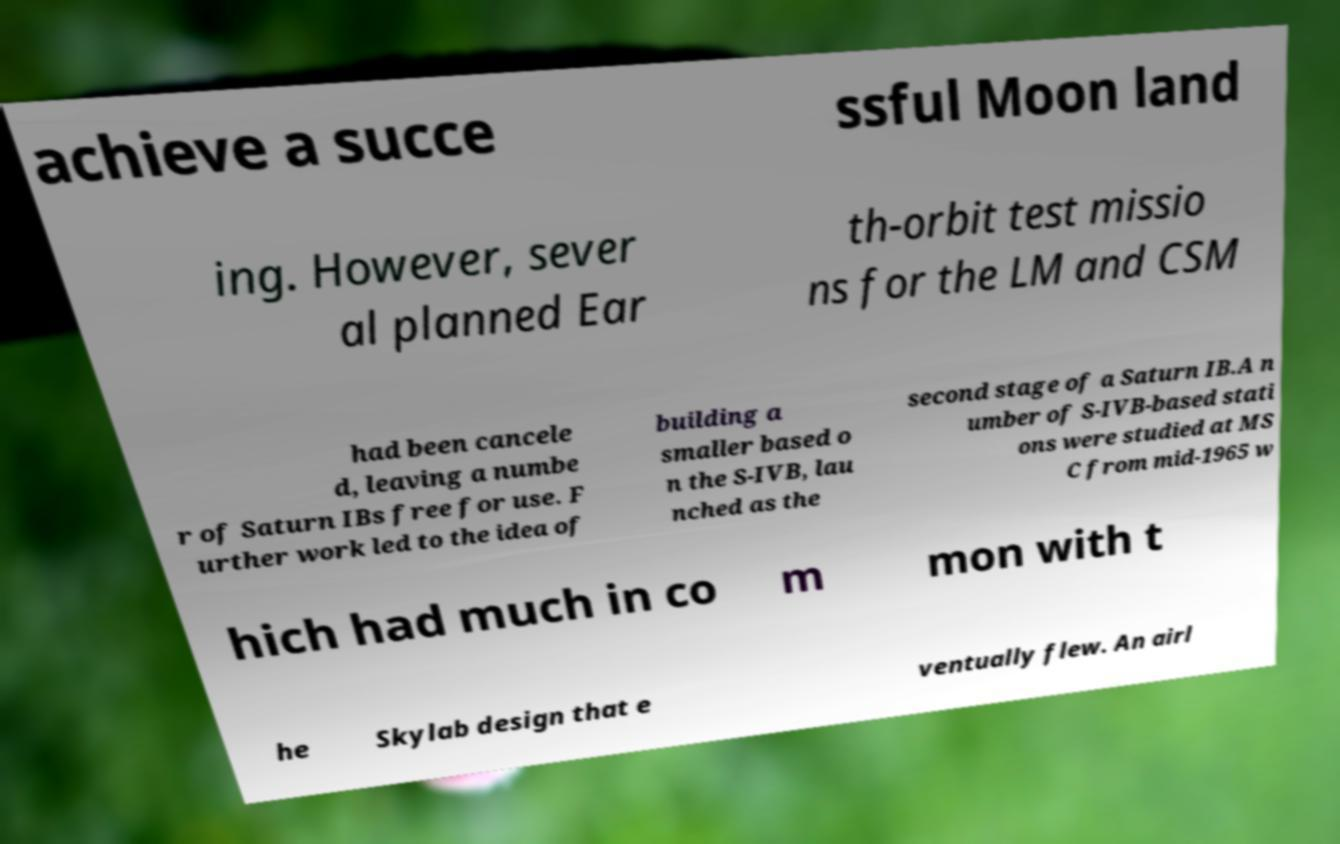Could you extract and type out the text from this image? achieve a succe ssful Moon land ing. However, sever al planned Ear th-orbit test missio ns for the LM and CSM had been cancele d, leaving a numbe r of Saturn IBs free for use. F urther work led to the idea of building a smaller based o n the S-IVB, lau nched as the second stage of a Saturn IB.A n umber of S-IVB-based stati ons were studied at MS C from mid-1965 w hich had much in co m mon with t he Skylab design that e ventually flew. An airl 